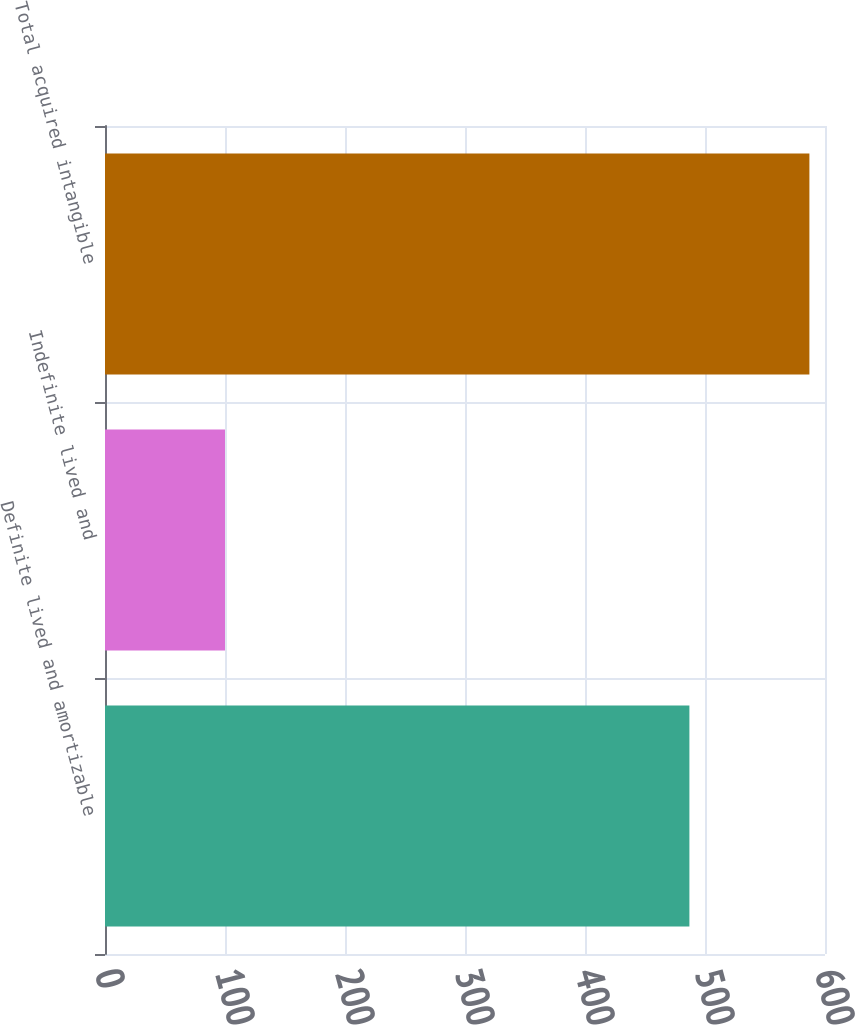Convert chart. <chart><loc_0><loc_0><loc_500><loc_500><bar_chart><fcel>Definite lived and amortizable<fcel>Indefinite lived and<fcel>Total acquired intangible<nl><fcel>487<fcel>100<fcel>587<nl></chart> 